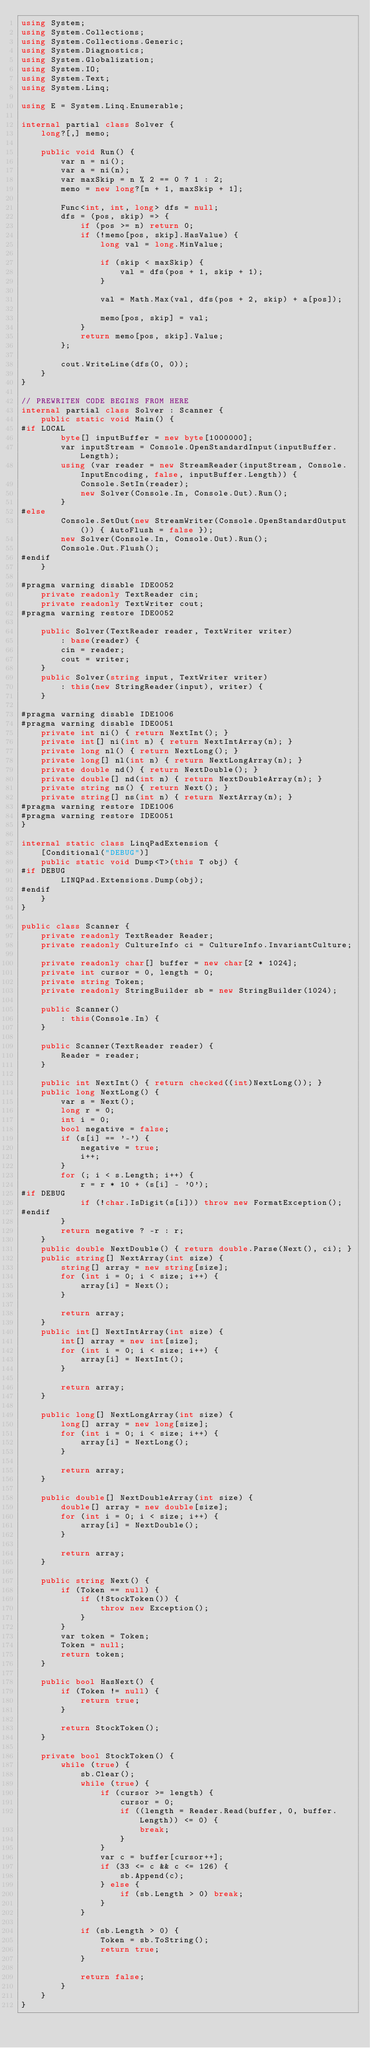Convert code to text. <code><loc_0><loc_0><loc_500><loc_500><_C#_>using System;
using System.Collections;
using System.Collections.Generic;
using System.Diagnostics;
using System.Globalization;
using System.IO;
using System.Text;
using System.Linq;

using E = System.Linq.Enumerable;

internal partial class Solver {
    long?[,] memo;

    public void Run() {
        var n = ni();
        var a = ni(n);
        var maxSkip = n % 2 == 0 ? 1 : 2;
        memo = new long?[n + 1, maxSkip + 1];

        Func<int, int, long> dfs = null;
        dfs = (pos, skip) => {
            if (pos >= n) return 0;
            if (!memo[pos, skip].HasValue) {
                long val = long.MinValue;

                if (skip < maxSkip) {
                    val = dfs(pos + 1, skip + 1);
                }

                val = Math.Max(val, dfs(pos + 2, skip) + a[pos]);

                memo[pos, skip] = val;
            }
            return memo[pos, skip].Value;
        };

        cout.WriteLine(dfs(0, 0));
    }
}

// PREWRITEN CODE BEGINS FROM HERE
internal partial class Solver : Scanner {
    public static void Main() {
#if LOCAL
        byte[] inputBuffer = new byte[1000000];
        var inputStream = Console.OpenStandardInput(inputBuffer.Length);
        using (var reader = new StreamReader(inputStream, Console.InputEncoding, false, inputBuffer.Length)) {
            Console.SetIn(reader);
            new Solver(Console.In, Console.Out).Run();
        }
#else
        Console.SetOut(new StreamWriter(Console.OpenStandardOutput()) { AutoFlush = false });
        new Solver(Console.In, Console.Out).Run();
        Console.Out.Flush();
#endif
    }

#pragma warning disable IDE0052
    private readonly TextReader cin;
    private readonly TextWriter cout;
#pragma warning restore IDE0052

    public Solver(TextReader reader, TextWriter writer)
        : base(reader) {
        cin = reader;
        cout = writer;
    }
    public Solver(string input, TextWriter writer)
        : this(new StringReader(input), writer) {
    }

#pragma warning disable IDE1006
#pragma warning disable IDE0051
    private int ni() { return NextInt(); }
    private int[] ni(int n) { return NextIntArray(n); }
    private long nl() { return NextLong(); }
    private long[] nl(int n) { return NextLongArray(n); }
    private double nd() { return NextDouble(); }
    private double[] nd(int n) { return NextDoubleArray(n); }
    private string ns() { return Next(); }
    private string[] ns(int n) { return NextArray(n); }
#pragma warning restore IDE1006
#pragma warning restore IDE0051
}

internal static class LinqPadExtension {
    [Conditional("DEBUG")]
    public static void Dump<T>(this T obj) {
#if DEBUG
        LINQPad.Extensions.Dump(obj);
#endif
    }
}

public class Scanner {
    private readonly TextReader Reader;
    private readonly CultureInfo ci = CultureInfo.InvariantCulture;

    private readonly char[] buffer = new char[2 * 1024];
    private int cursor = 0, length = 0;
    private string Token;
    private readonly StringBuilder sb = new StringBuilder(1024);

    public Scanner()
        : this(Console.In) {
    }

    public Scanner(TextReader reader) {
        Reader = reader;
    }

    public int NextInt() { return checked((int)NextLong()); }
    public long NextLong() {
        var s = Next();
        long r = 0;
        int i = 0;
        bool negative = false;
        if (s[i] == '-') {
            negative = true;
            i++;
        }
        for (; i < s.Length; i++) {
            r = r * 10 + (s[i] - '0');
#if DEBUG
            if (!char.IsDigit(s[i])) throw new FormatException();
#endif
        }
        return negative ? -r : r;
    }
    public double NextDouble() { return double.Parse(Next(), ci); }
    public string[] NextArray(int size) {
        string[] array = new string[size];
        for (int i = 0; i < size; i++) {
            array[i] = Next();
        }

        return array;
    }
    public int[] NextIntArray(int size) {
        int[] array = new int[size];
        for (int i = 0; i < size; i++) {
            array[i] = NextInt();
        }

        return array;
    }

    public long[] NextLongArray(int size) {
        long[] array = new long[size];
        for (int i = 0; i < size; i++) {
            array[i] = NextLong();
        }

        return array;
    }

    public double[] NextDoubleArray(int size) {
        double[] array = new double[size];
        for (int i = 0; i < size; i++) {
            array[i] = NextDouble();
        }

        return array;
    }

    public string Next() {
        if (Token == null) {
            if (!StockToken()) {
                throw new Exception();
            }
        }
        var token = Token;
        Token = null;
        return token;
    }

    public bool HasNext() {
        if (Token != null) {
            return true;
        }

        return StockToken();
    }

    private bool StockToken() {
        while (true) {
            sb.Clear();
            while (true) {
                if (cursor >= length) {
                    cursor = 0;
                    if ((length = Reader.Read(buffer, 0, buffer.Length)) <= 0) {
                        break;
                    }
                }
                var c = buffer[cursor++];
                if (33 <= c && c <= 126) {
                    sb.Append(c);
                } else {
                    if (sb.Length > 0) break;
                }
            }

            if (sb.Length > 0) {
                Token = sb.ToString();
                return true;
            }

            return false;
        }
    }
}</code> 